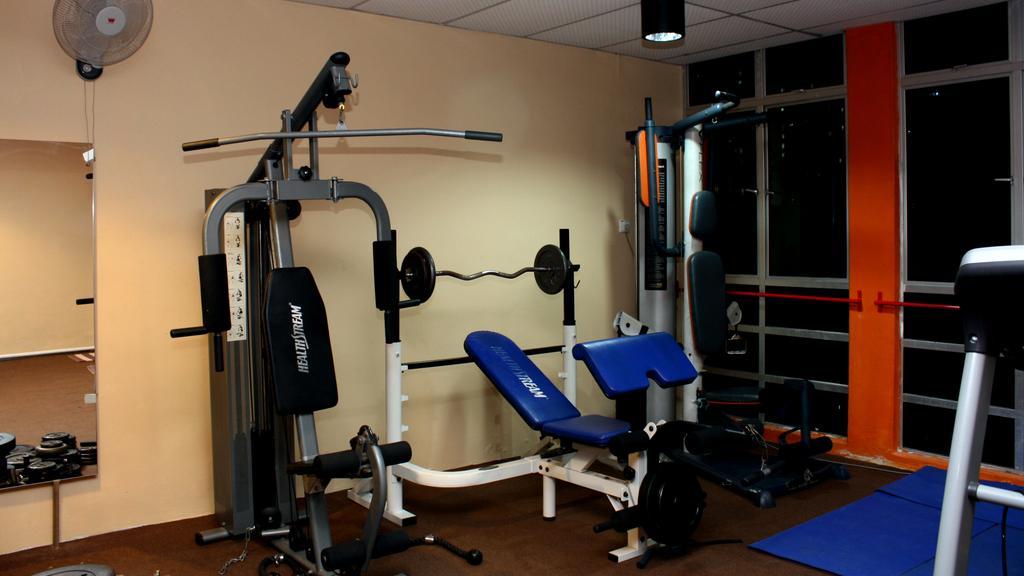In one or two sentences, can you explain what this image depicts? This is an inside view of a room. Here I can see few gym equipment on the floor. On the right side there is a glass. On the left side there is a mirror is attached to the wall, at the top of it there is a fan. 